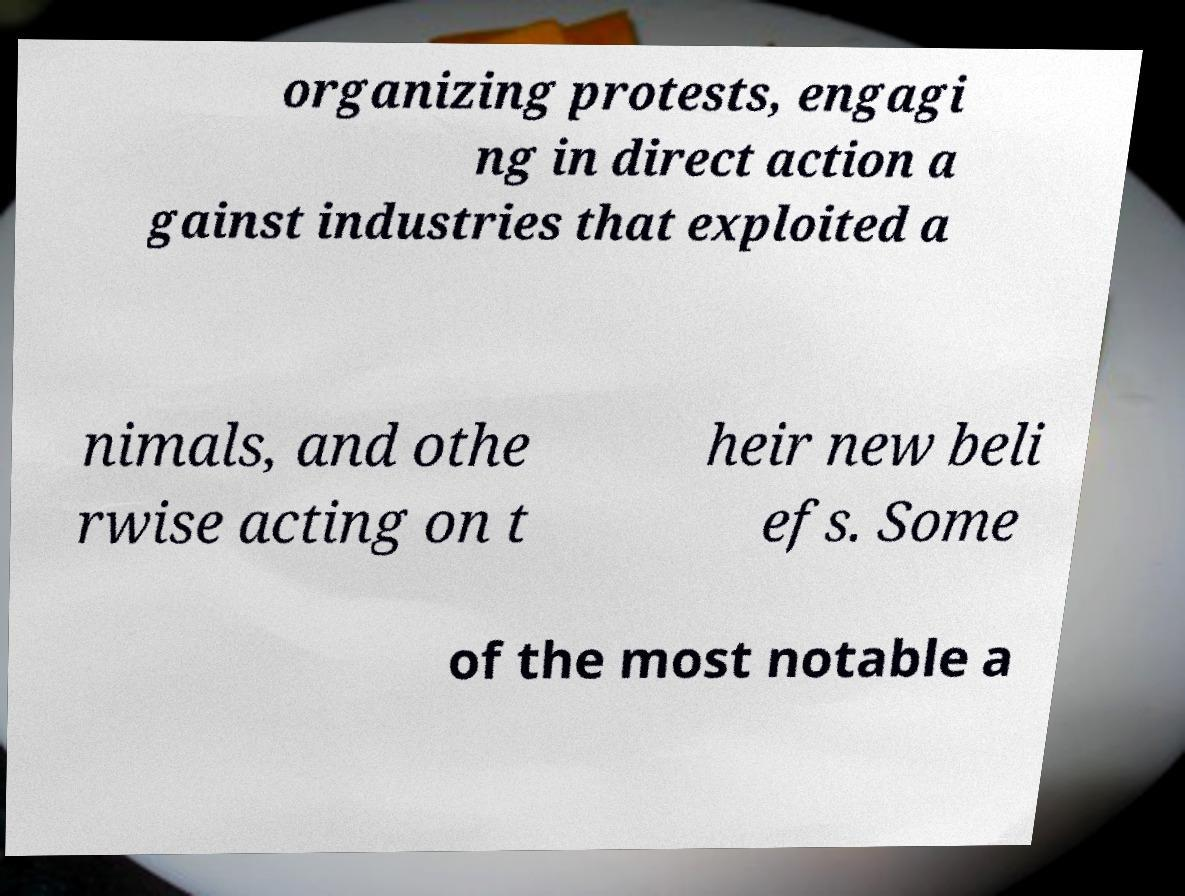Can you read and provide the text displayed in the image?This photo seems to have some interesting text. Can you extract and type it out for me? organizing protests, engagi ng in direct action a gainst industries that exploited a nimals, and othe rwise acting on t heir new beli efs. Some of the most notable a 